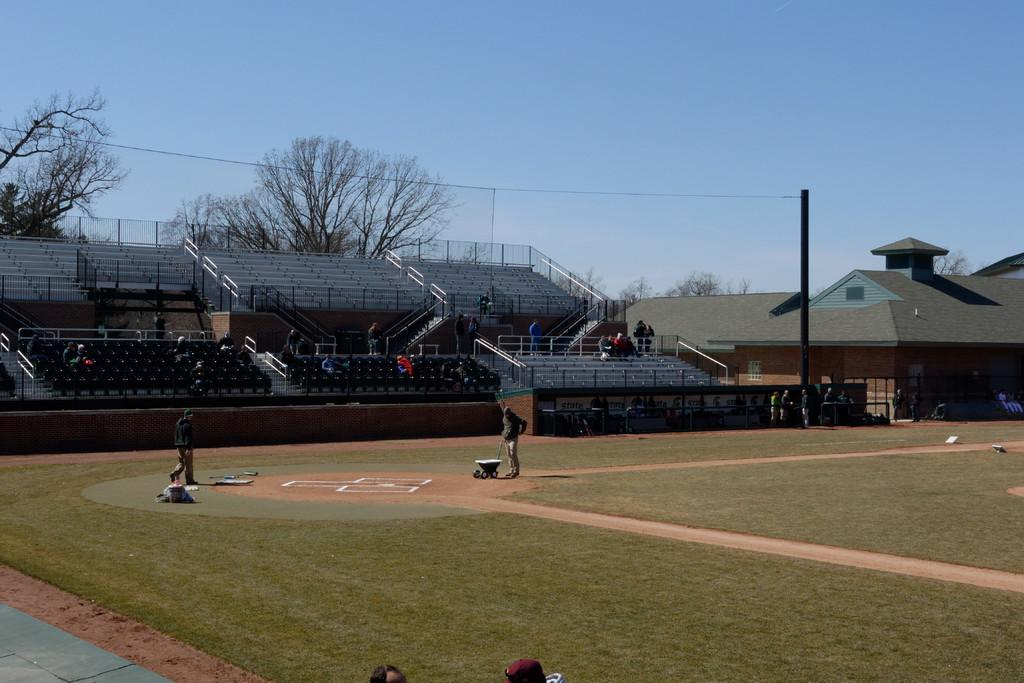What type of structure is present in the image? There are stairs, chairs, and buildings in the image. Who or what can be seen in the image? There are people in the image. What type of natural elements are present in the image? There are trees and grass in the image. What is visible at the top of the image? The sky is visible at the top of the image. Can you see a cow wearing a chain in the image? No, there is no cow or chain present in the image. Where is the pocket located in the image? There is no pocket present in the image. 